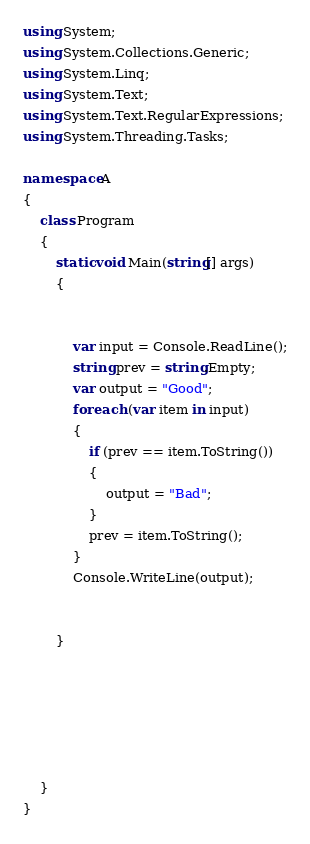<code> <loc_0><loc_0><loc_500><loc_500><_C#_>using System;
using System.Collections.Generic;
using System.Linq;
using System.Text;
using System.Text.RegularExpressions;
using System.Threading.Tasks;

namespace A
{
    class Program
    {
        static void Main(string[] args)
        {


            var input = Console.ReadLine();
            string prev = string.Empty;
            var output = "Good";
            foreach (var item in input)
            {
                if (prev == item.ToString())
                {
                    output = "Bad";
                }
                prev = item.ToString();
            }
            Console.WriteLine(output);


        }




       

    }
}
</code> 